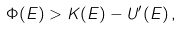Convert formula to latex. <formula><loc_0><loc_0><loc_500><loc_500>\Phi ( E ) > K ( E ) - U ^ { \prime } ( E ) \, ,</formula> 